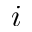Convert formula to latex. <formula><loc_0><loc_0><loc_500><loc_500>i</formula> 